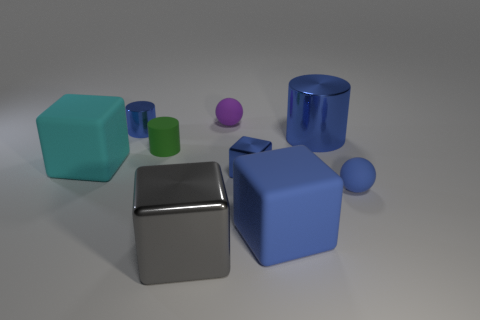Subtract all spheres. How many objects are left? 7 Subtract 0 yellow cubes. How many objects are left? 9 Subtract all metallic cylinders. Subtract all small blue rubber things. How many objects are left? 6 Add 2 tiny blue metal things. How many tiny blue metal things are left? 4 Add 1 small blue metal objects. How many small blue metal objects exist? 3 